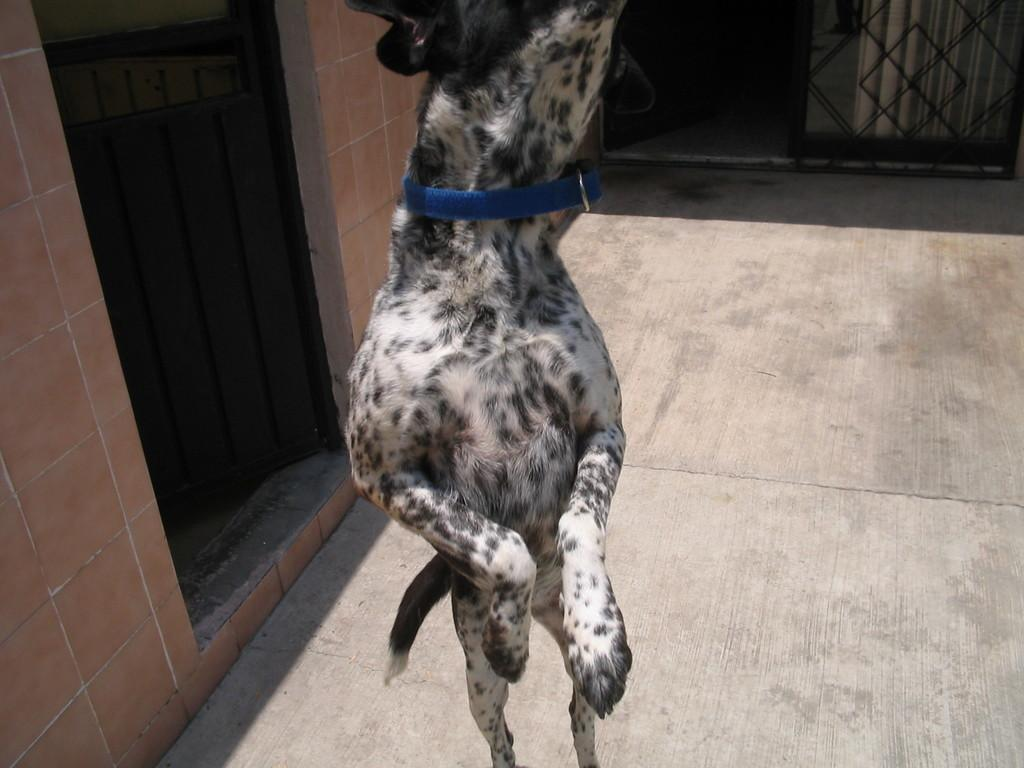What type of animal is in the image? There is a dog in the image. Can you describe the dog's appearance? The dog is white and black in color. What is visible in the background of the image? There is a wall visible in the image. What is the color of the gate in the image? There is a black color gate in the image. What type of cart is being controlled by the zebra in the image? There is no zebra or cart present in the image; it features a dog. 